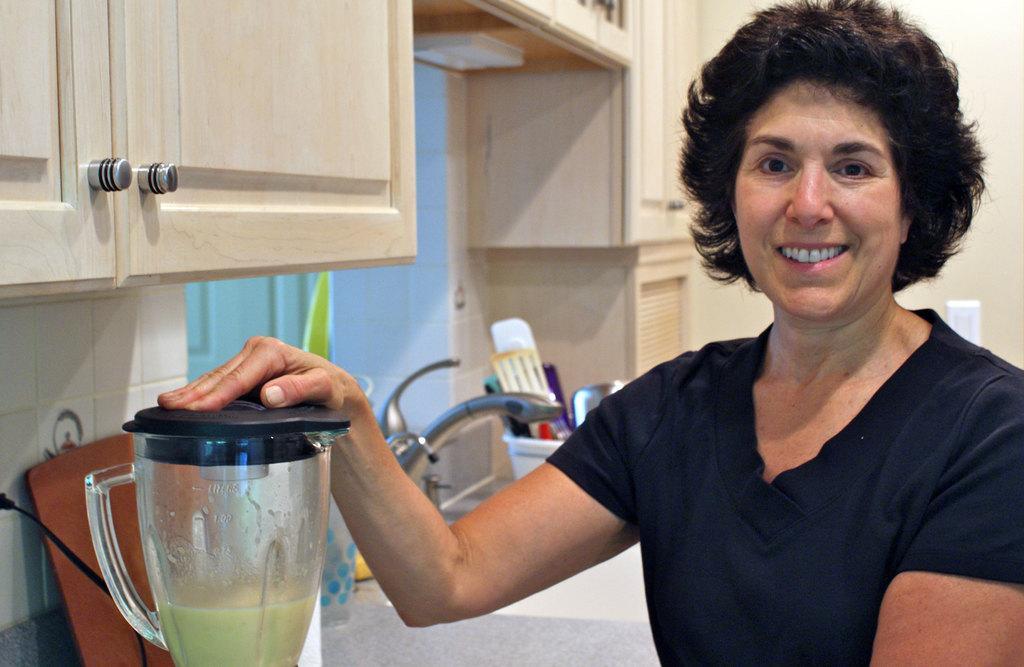Describe this image in one or two sentences. In this image I can see a woman and I can see smile on her face. I can also see she is wearing black colour dress. Here I can see a juicer and in background I can see cupboards and a water tap. 